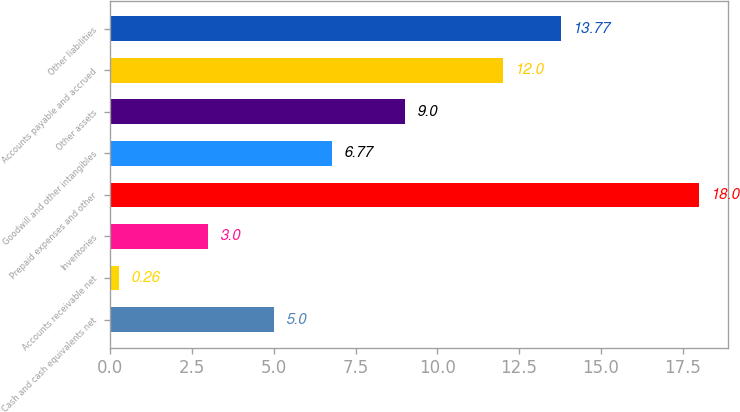Convert chart. <chart><loc_0><loc_0><loc_500><loc_500><bar_chart><fcel>Cash and cash equivalents net<fcel>Accounts receivable net<fcel>Inventories<fcel>Prepaid expenses and other<fcel>Goodwill and other intangibles<fcel>Other assets<fcel>Accounts payable and accrued<fcel>Other liabilities<nl><fcel>5<fcel>0.26<fcel>3<fcel>18<fcel>6.77<fcel>9<fcel>12<fcel>13.77<nl></chart> 